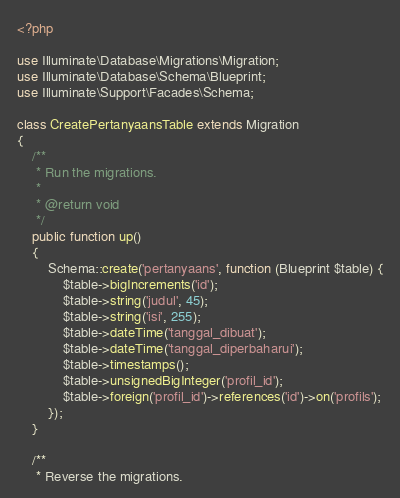Convert code to text. <code><loc_0><loc_0><loc_500><loc_500><_PHP_><?php

use Illuminate\Database\Migrations\Migration;
use Illuminate\Database\Schema\Blueprint;
use Illuminate\Support\Facades\Schema;

class CreatePertanyaansTable extends Migration
{
    /**
     * Run the migrations.
     *
     * @return void
     */
    public function up()
    {
        Schema::create('pertanyaans', function (Blueprint $table) {
            $table->bigIncrements('id');
            $table->string('judul', 45);
            $table->string('isi', 255);
            $table->dateTime('tanggal_dibuat');
            $table->dateTime('tanggal_diperbaharui');
            $table->timestamps();
            $table->unsignedBigInteger('profil_id');
            $table->foreign('profil_id')->references('id')->on('profils');
        });
    }

    /**
     * Reverse the migrations.</code> 